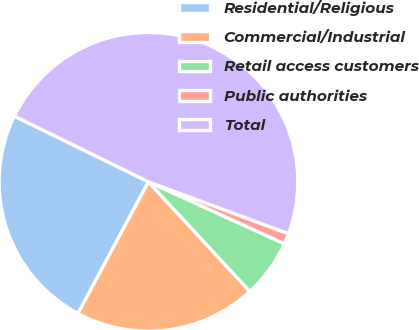Convert chart. <chart><loc_0><loc_0><loc_500><loc_500><pie_chart><fcel>Residential/Religious<fcel>Commercial/Industrial<fcel>Retail access customers<fcel>Public authorities<fcel>Total<nl><fcel>24.43%<fcel>19.7%<fcel>6.32%<fcel>1.16%<fcel>48.39%<nl></chart> 